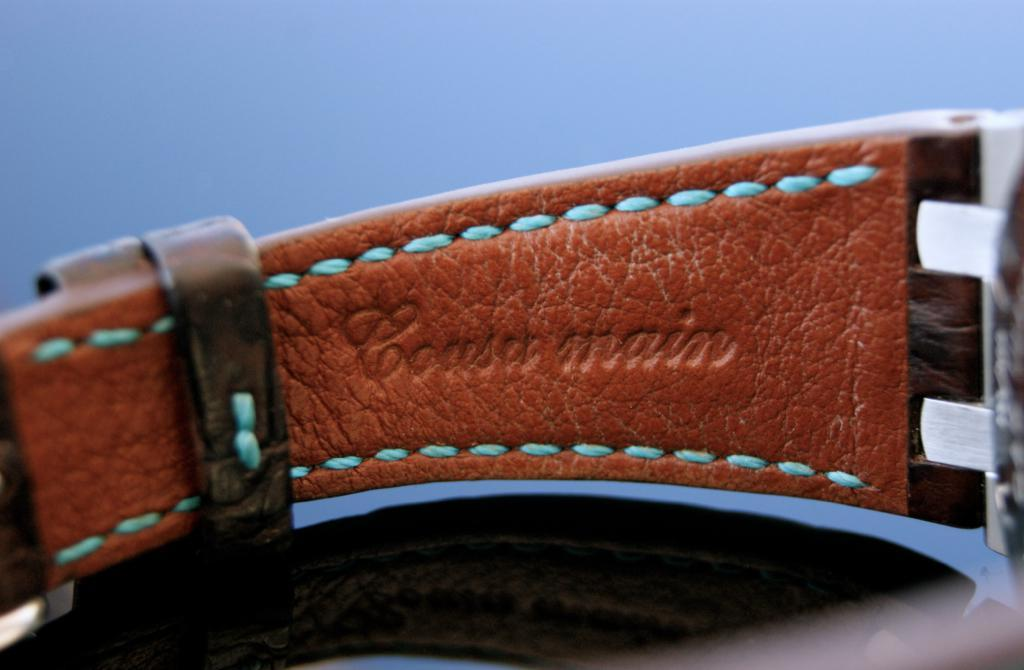Provide a one-sentence caption for the provided image. Coasa main wrote on a type of belt. 